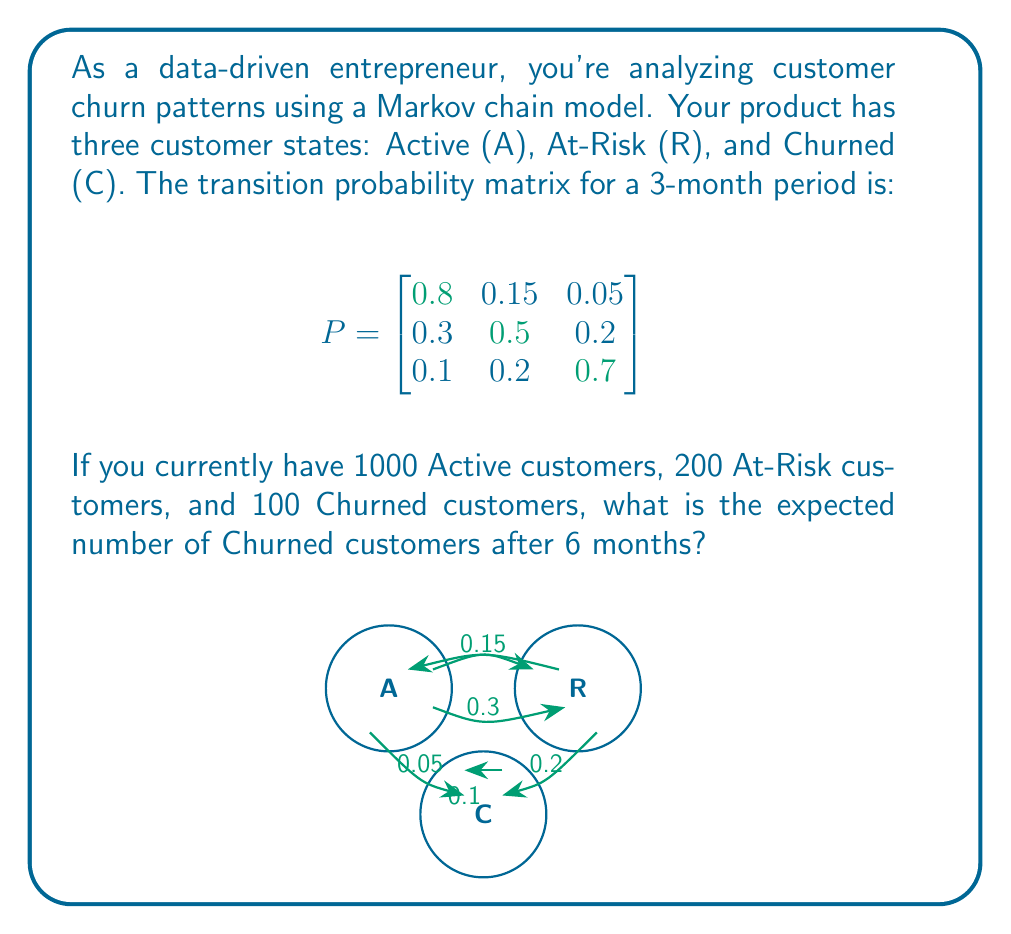Help me with this question. Let's approach this step-by-step:

1) First, we need to calculate $P^2$ to get the transition probabilities for a 6-month period. We can do this by multiplying the matrix by itself:

   $$P^2 = P \times P = \begin{bmatrix}
   0.67 & 0.2175 & 0.1125 \\
   0.39 & 0.3925 & 0.2175 \\
   0.22 & 0.29 & 0.49
   \end{bmatrix}$$

2) Now, we need to set up our initial state vector. With 1000 Active, 200 At-Risk, and 100 Churned customers, our initial state vector is:

   $$\mathbf{v}_0 = \begin{bmatrix} 1000 & 200 & 100 \end{bmatrix}$$

3) To find the state after 6 months, we multiply our initial state vector by $P^2$:

   $$\mathbf{v}_6 = \mathbf{v}_0 \times P^2$$

4) Let's perform this multiplication:

   $$\begin{aligned}
   \mathbf{v}_6 &= \begin{bmatrix} 1000 & 200 & 100 \end{bmatrix} \times 
   \begin{bmatrix}
   0.67 & 0.2175 & 0.1125 \\
   0.39 & 0.3925 & 0.2175 \\
   0.22 & 0.29 & 0.49
   \end{bmatrix} \\
   &= \begin{bmatrix} 670 + 78 + 22 & 217.5 + 78.5 + 29 & 112.5 + 43.5 + 49 \end{bmatrix} \\
   &= \begin{bmatrix} 770 & 325 & 205 \end{bmatrix}
   \end{aligned}$$

5) The last element in this vector represents the number of Churned customers after 6 months.
Answer: 205 Churned customers 